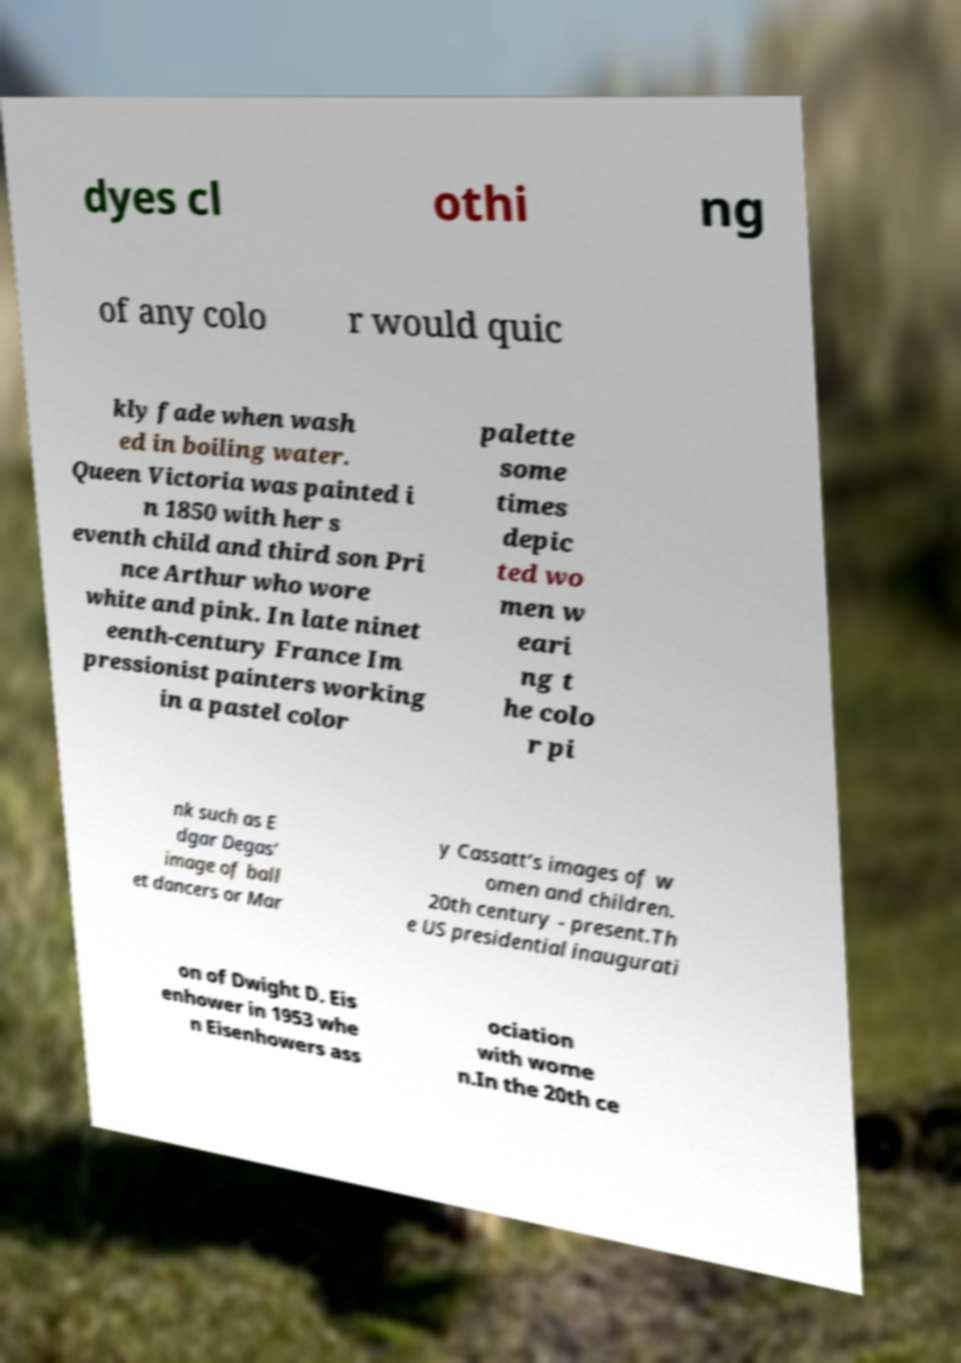Please read and relay the text visible in this image. What does it say? dyes cl othi ng of any colo r would quic kly fade when wash ed in boiling water. Queen Victoria was painted i n 1850 with her s eventh child and third son Pri nce Arthur who wore white and pink. In late ninet eenth-century France Im pressionist painters working in a pastel color palette some times depic ted wo men w eari ng t he colo r pi nk such as E dgar Degas’ image of ball et dancers or Mar y Cassatt’s images of w omen and children. 20th century - present.Th e US presidential inaugurati on of Dwight D. Eis enhower in 1953 whe n Eisenhowers ass ociation with wome n.In the 20th ce 